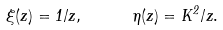<formula> <loc_0><loc_0><loc_500><loc_500>\xi ( z ) = 1 / z , \quad \ \eta ( z ) = K ^ { 2 } / z .</formula> 